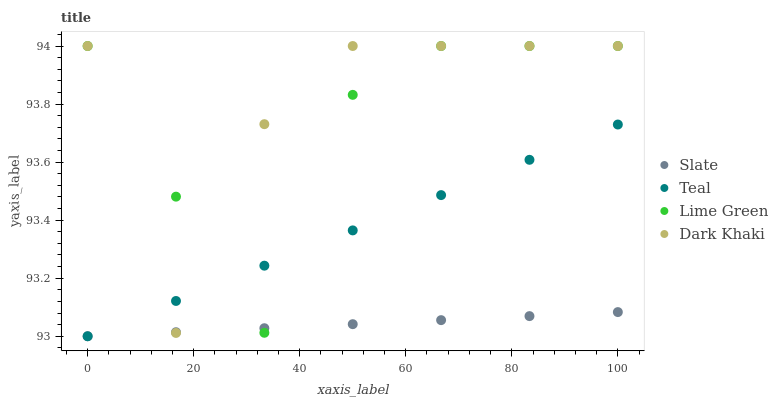Does Slate have the minimum area under the curve?
Answer yes or no. Yes. Does Dark Khaki have the maximum area under the curve?
Answer yes or no. Yes. Does Lime Green have the minimum area under the curve?
Answer yes or no. No. Does Lime Green have the maximum area under the curve?
Answer yes or no. No. Is Slate the smoothest?
Answer yes or no. Yes. Is Dark Khaki the roughest?
Answer yes or no. Yes. Is Lime Green the smoothest?
Answer yes or no. No. Is Lime Green the roughest?
Answer yes or no. No. Does Slate have the lowest value?
Answer yes or no. Yes. Does Lime Green have the lowest value?
Answer yes or no. No. Does Lime Green have the highest value?
Answer yes or no. Yes. Does Slate have the highest value?
Answer yes or no. No. Does Slate intersect Teal?
Answer yes or no. Yes. Is Slate less than Teal?
Answer yes or no. No. Is Slate greater than Teal?
Answer yes or no. No. 